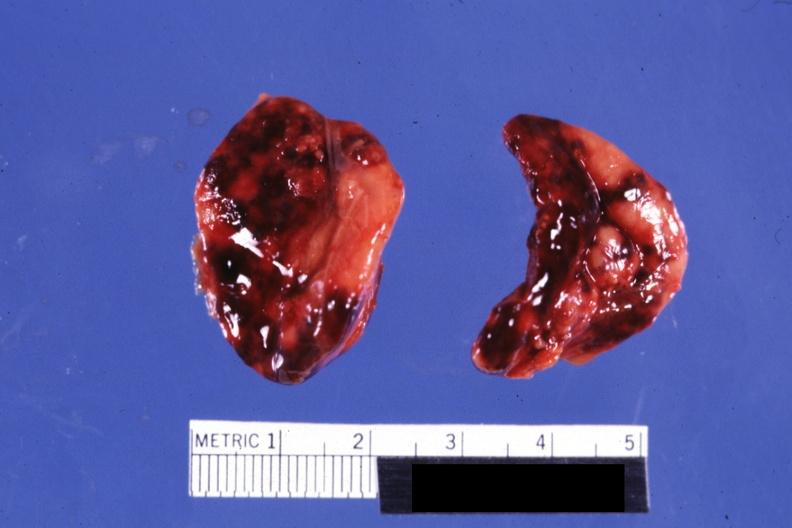s hemorrhage newborn present?
Answer the question using a single word or phrase. Yes 